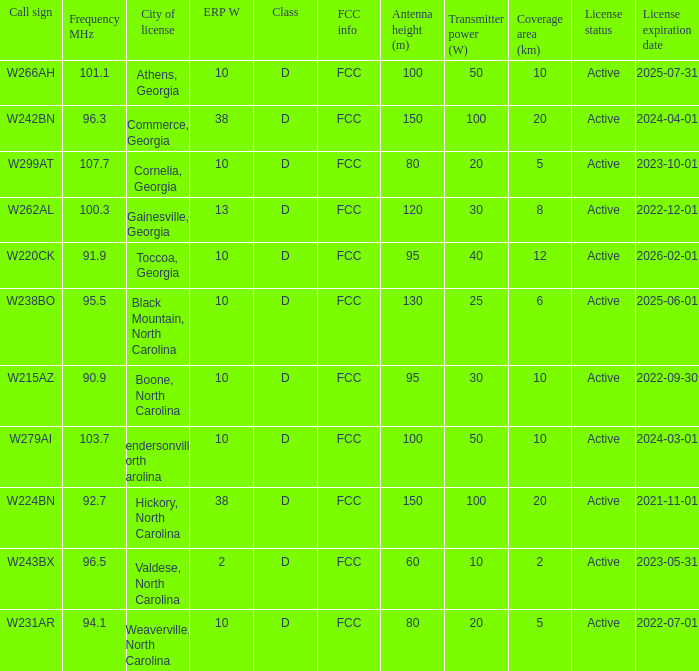What is the FCC frequency for the station w262al which has a Frequency MHz larger than 92.7? FCC. Would you be able to parse every entry in this table? {'header': ['Call sign', 'Frequency MHz', 'City of license', 'ERP W', 'Class', 'FCC info', 'Antenna height (m)', 'Transmitter power (W)', 'Coverage area (km)', 'License status', 'License expiration date'], 'rows': [['W266AH', '101.1', 'Athens, Georgia', '10', 'D', 'FCC', '100', '50', '10', 'Active', '2025-07-31'], ['W242BN', '96.3', 'Commerce, Georgia', '38', 'D', 'FCC', '150', '100', '20', 'Active', '2024-04-01'], ['W299AT', '107.7', 'Cornelia, Georgia', '10', 'D', 'FCC', '80', '20', '5', 'Active', '2023-10-01'], ['W262AL', '100.3', 'Gainesville, Georgia', '13', 'D', 'FCC', '120', '30', '8', 'Active', '2022-12-01'], ['W220CK', '91.9', 'Toccoa, Georgia', '10', 'D', 'FCC', '95', '40', '12', 'Active', '2026-02-01'], ['W238BO', '95.5', 'Black Mountain, North Carolina', '10', 'D', 'FCC', '130', '25', '6', 'Active', '2025-06-01'], ['W215AZ', '90.9', 'Boone, North Carolina', '10', 'D', 'FCC', '95', '30', '10', 'Active', '2022-09-30'], ['W279AI', '103.7', 'Hendersonville, North Carolina', '10', 'D', 'FCC', '100', '50', '10', 'Active', '2024-03-01'], ['W224BN', '92.7', 'Hickory, North Carolina', '38', 'D', 'FCC', '150', '100', '20', 'Active', '2021-11-01'], ['W243BX', '96.5', 'Valdese, North Carolina', '2', 'D', 'FCC', '60', '10', '2', 'Active', '2023-05-31'], ['W231AR', '94.1', 'Weaverville, North Carolina', '10', 'D', 'FCC', '80', '20', '5', 'Active', '2022-07-01']]} 